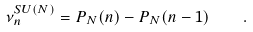Convert formula to latex. <formula><loc_0><loc_0><loc_500><loc_500>\nu _ { n } ^ { S U ( N ) } = P _ { N } ( n ) - P _ { N } ( n - 1 ) \quad .</formula> 